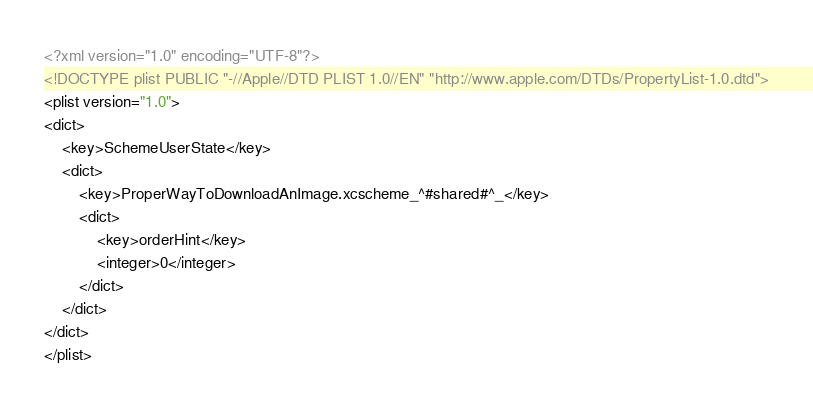Convert code to text. <code><loc_0><loc_0><loc_500><loc_500><_XML_><?xml version="1.0" encoding="UTF-8"?>
<!DOCTYPE plist PUBLIC "-//Apple//DTD PLIST 1.0//EN" "http://www.apple.com/DTDs/PropertyList-1.0.dtd">
<plist version="1.0">
<dict>
	<key>SchemeUserState</key>
	<dict>
		<key>ProperWayToDownloadAnImage.xcscheme_^#shared#^_</key>
		<dict>
			<key>orderHint</key>
			<integer>0</integer>
		</dict>
	</dict>
</dict>
</plist>
</code> 